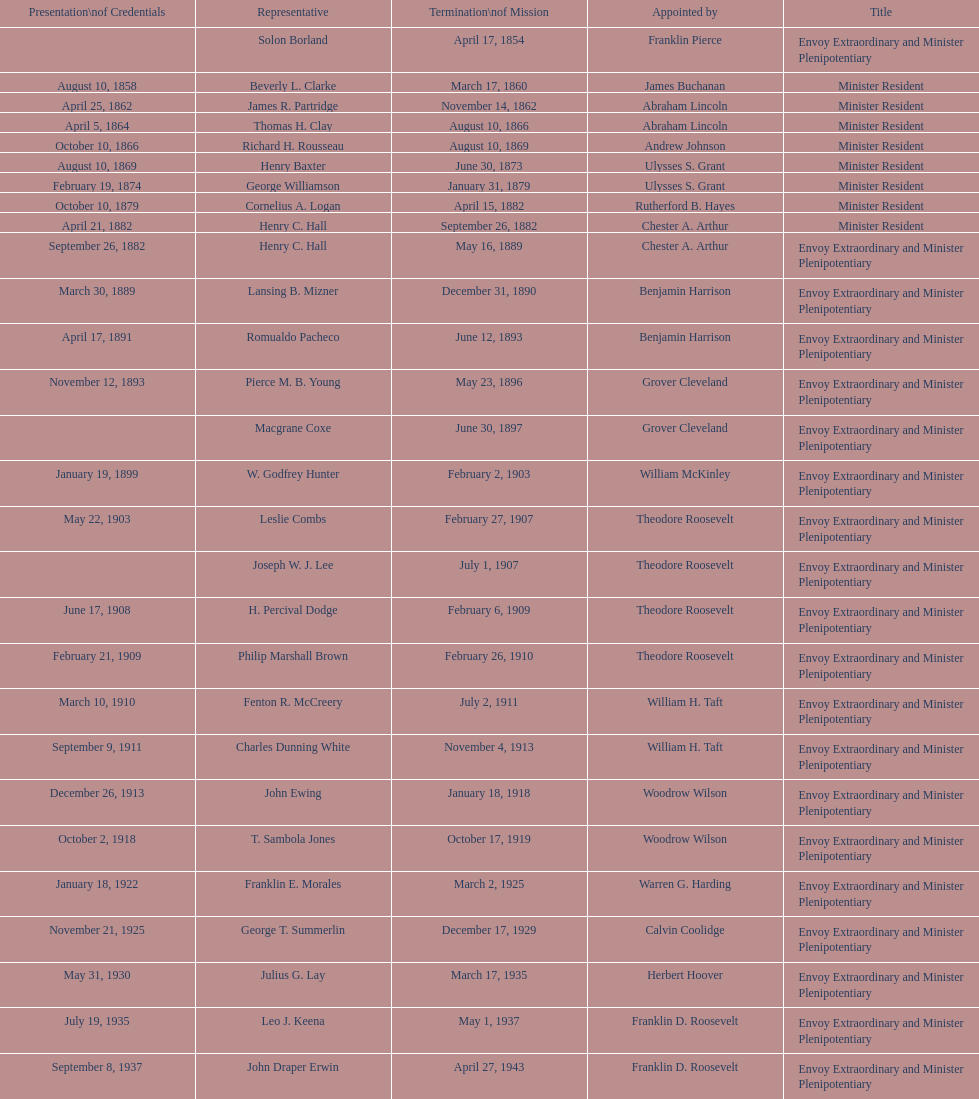Which date is below april 17, 1854 March 17, 1860. 